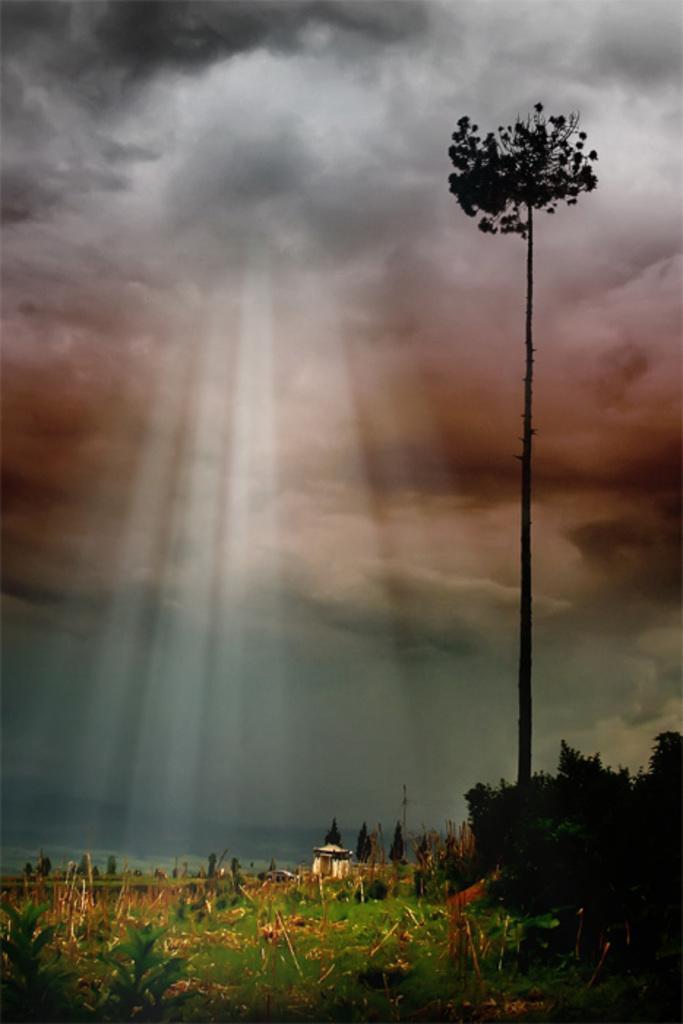How would you summarize this image in a sentence or two? In this picture i can see trees, plants, grass and sky. 